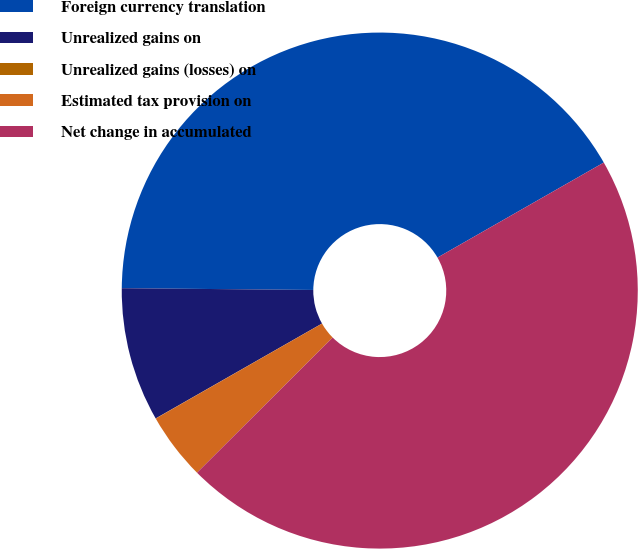<chart> <loc_0><loc_0><loc_500><loc_500><pie_chart><fcel>Foreign currency translation<fcel>Unrealized gains on<fcel>Unrealized gains (losses) on<fcel>Estimated tax provision on<fcel>Net change in accumulated<nl><fcel>41.59%<fcel>8.4%<fcel>0.01%<fcel>4.21%<fcel>45.79%<nl></chart> 